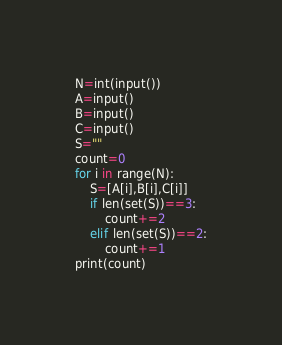<code> <loc_0><loc_0><loc_500><loc_500><_Python_>N=int(input())
A=input()
B=input()
C=input()
S=""
count=0
for i in range(N):
	S=[A[i],B[i],C[i]]
	if len(set(S))==3:
		count+=2
	elif len(set(S))==2:
		count+=1
print(count)</code> 